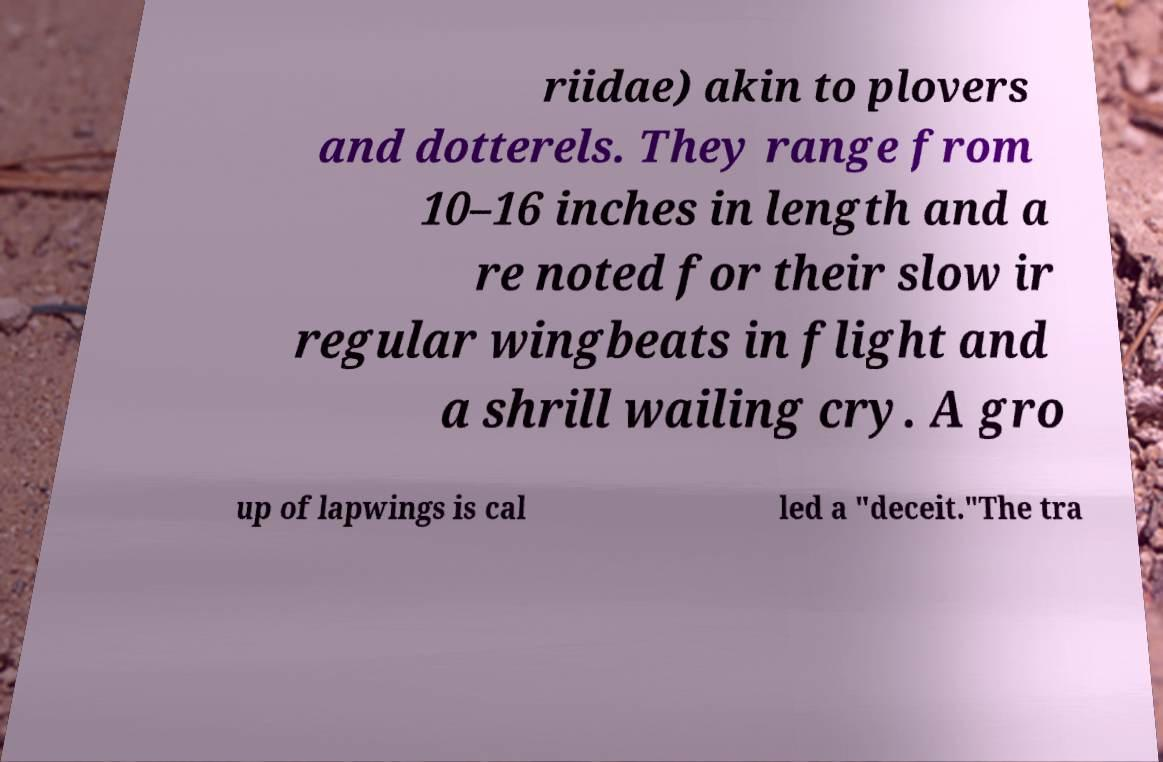Please identify and transcribe the text found in this image. riidae) akin to plovers and dotterels. They range from 10–16 inches in length and a re noted for their slow ir regular wingbeats in flight and a shrill wailing cry. A gro up of lapwings is cal led a "deceit."The tra 